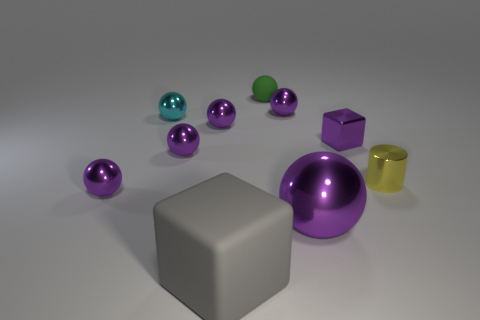There is a cube that is to the right of the rubber thing behind the tiny object on the right side of the small cube; what is its color?
Give a very brief answer. Purple. How many blue things are cylinders or matte things?
Offer a terse response. 0. What number of other things are the same size as the green rubber object?
Provide a short and direct response. 7. What number of small brown blocks are there?
Make the answer very short. 0. Are there any other things that are the same shape as the small yellow thing?
Your answer should be compact. No. Is the cube to the left of the green object made of the same material as the small green ball that is behind the purple block?
Give a very brief answer. Yes. What is the big gray object made of?
Give a very brief answer. Rubber. What number of balls are made of the same material as the large block?
Your answer should be very brief. 1. How many matte objects are either purple balls or big purple things?
Offer a terse response. 0. There is a shiny object that is right of the tiny block; is its shape the same as the rubber object that is on the left side of the tiny matte sphere?
Provide a short and direct response. No. 